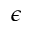Convert formula to latex. <formula><loc_0><loc_0><loc_500><loc_500>\epsilon</formula> 